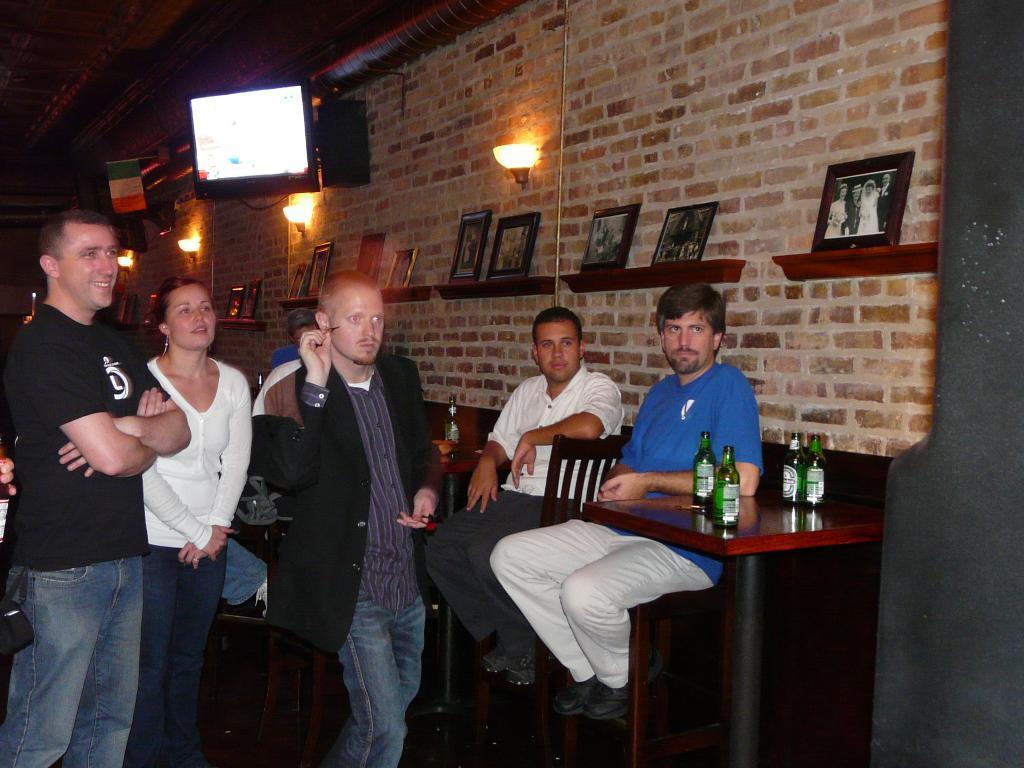Please provide a concise description of this image. This picture is clicked inside a restaurant. There are people sitting on chairs at the tables and some of them are standing. On the table there are bottles. To the wall there are open shelves and in it there are picture frames. There is television and wall lamps on the wall.  